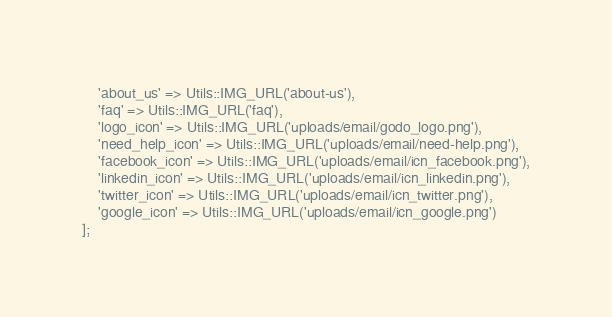Convert code to text. <code><loc_0><loc_0><loc_500><loc_500><_PHP_>    'about_us' => Utils::IMG_URL('about-us'),
    'faq' => Utils::IMG_URL('faq'),
    'logo_icon' => Utils::IMG_URL('uploads/email/godo_logo.png'),
    'need_help_icon' => Utils::IMG_URL('uploads/email/need-help.png'),
    'facebook_icon' => Utils::IMG_URL('uploads/email/icn_facebook.png'),
    'linkedin_icon' => Utils::IMG_URL('uploads/email/icn_linkedin.png'),
    'twitter_icon' => Utils::IMG_URL('uploads/email/icn_twitter.png'),
    'google_icon' => Utils::IMG_URL('uploads/email/icn_google.png') 
];
</code> 